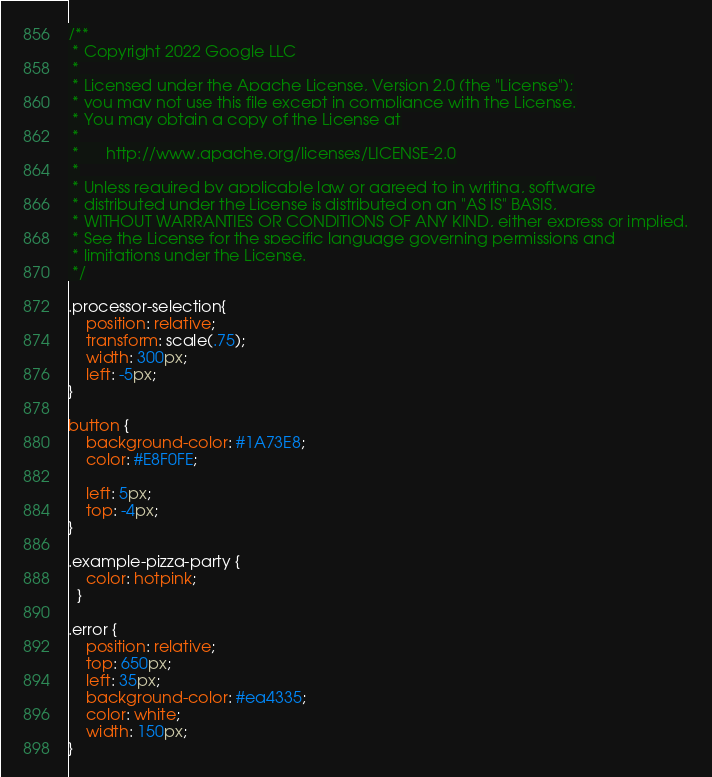Convert code to text. <code><loc_0><loc_0><loc_500><loc_500><_CSS_>/**
 * Copyright 2022 Google LLC
 *
 * Licensed under the Apache License, Version 2.0 (the "License");
 * you may not use this file except in compliance with the License.
 * You may obtain a copy of the License at
 *
 *      http://www.apache.org/licenses/LICENSE-2.0
 *
 * Unless required by applicable law or agreed to in writing, software
 * distributed under the License is distributed on an "AS IS" BASIS,
 * WITHOUT WARRANTIES OR CONDITIONS OF ANY KIND, either express or implied.
 * See the License for the specific language governing permissions and
 * limitations under the License.
 */

.processor-selection{
    position: relative;
    transform: scale(.75);
    width: 300px;
    left: -5px;
}

button {
    background-color: #1A73E8;
    color: #E8F0FE;

    left: 5px;
    top: -4px;
}

.example-pizza-party {
    color: hotpink;
  }

.error {
    position: relative;
    top: 650px;
    left: 35px;
    background-color: #ea4335;
    color: white;
    width: 150px;
}
</code> 